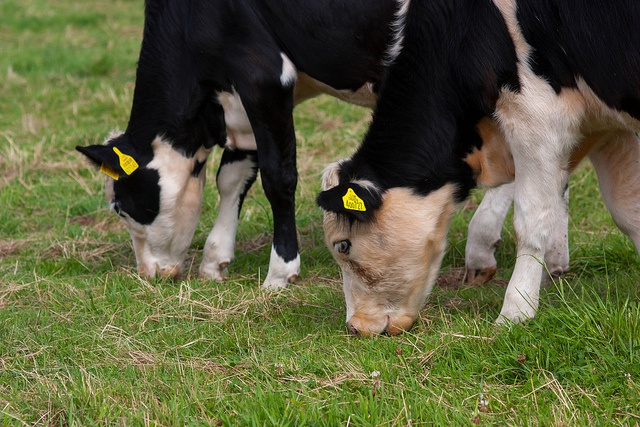Describe the objects in this image and their specific colors. I can see cow in olive, black, darkgray, and gray tones and cow in olive, black, darkgray, and gray tones in this image. 